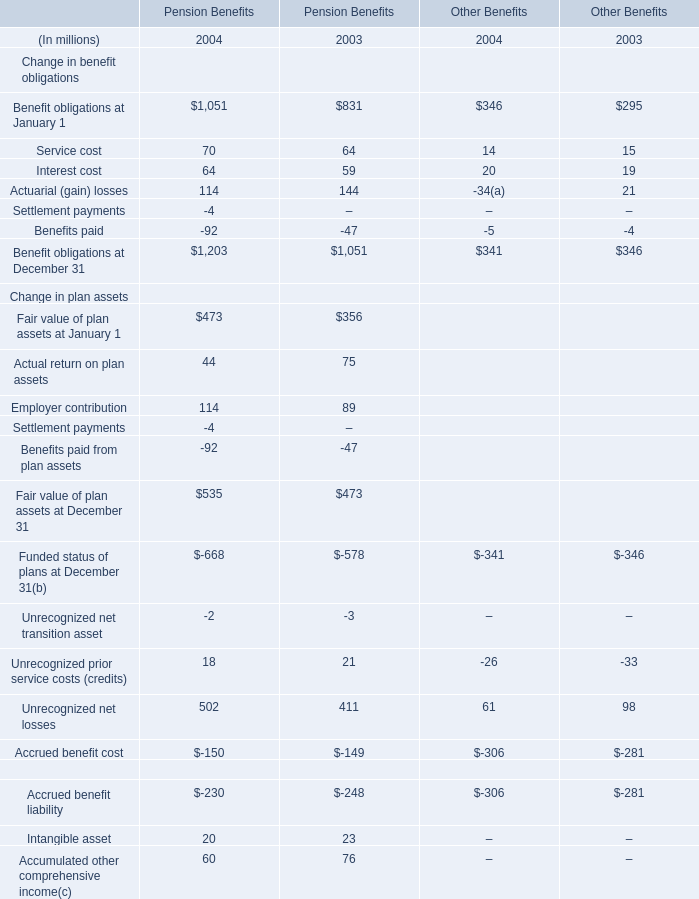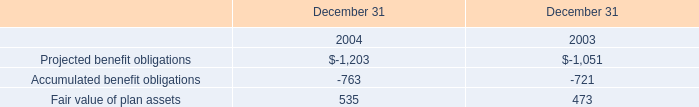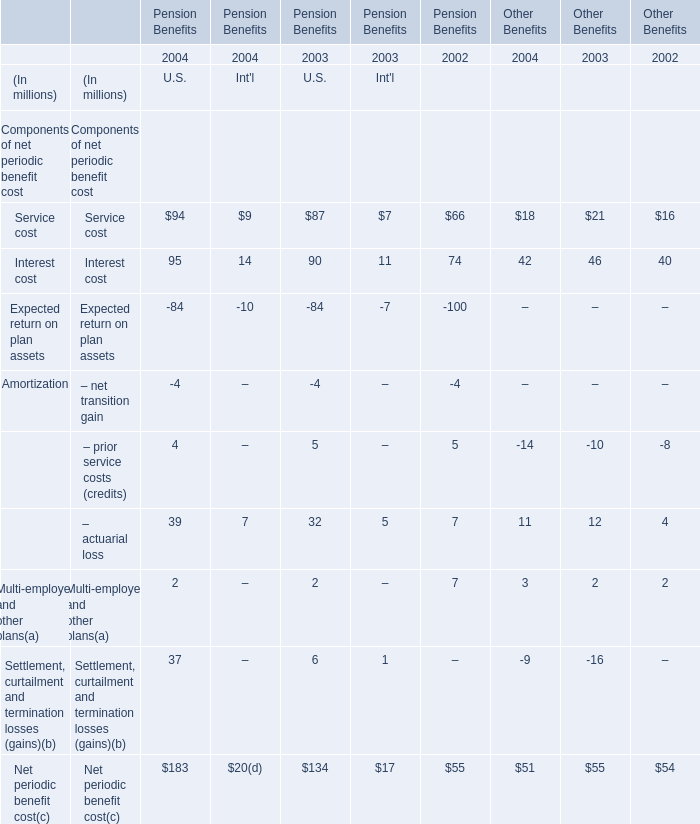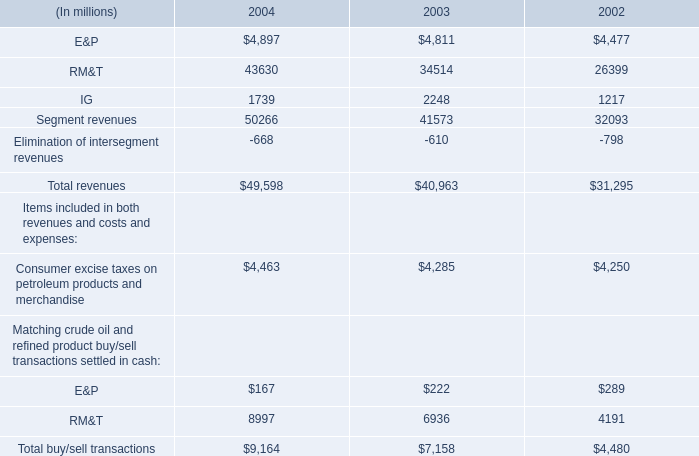At January 1,what year when Fair value of plan assets for Pension Benefits is higher how much is Benefit obligations for Pension Benefits? (in million) 
Answer: 1051. 